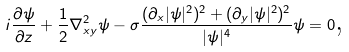<formula> <loc_0><loc_0><loc_500><loc_500>i \frac { \partial \psi } { \partial z } + \frac { 1 } { 2 } \nabla ^ { 2 } _ { x y } \psi - \sigma \frac { ( \partial _ { x } | \psi | ^ { 2 } ) ^ { 2 } + ( \partial _ { y } | \psi | ^ { 2 } ) ^ { 2 } } { | \psi | ^ { 4 } } \psi = 0 \text {,}</formula> 